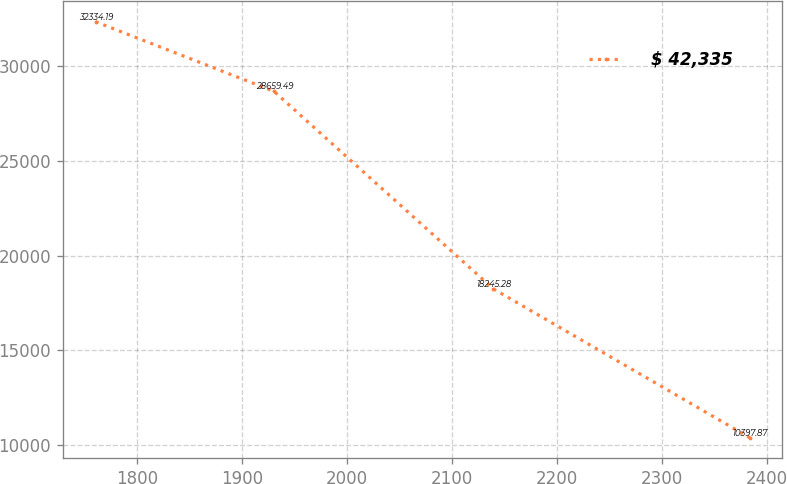Convert chart to OTSL. <chart><loc_0><loc_0><loc_500><loc_500><line_chart><ecel><fcel>$ 42,335<nl><fcel>1760.33<fcel>32334.2<nl><fcel>1930.44<fcel>28659.5<nl><fcel>2139.47<fcel>18245.3<nl><fcel>2383.84<fcel>10397.9<nl></chart> 